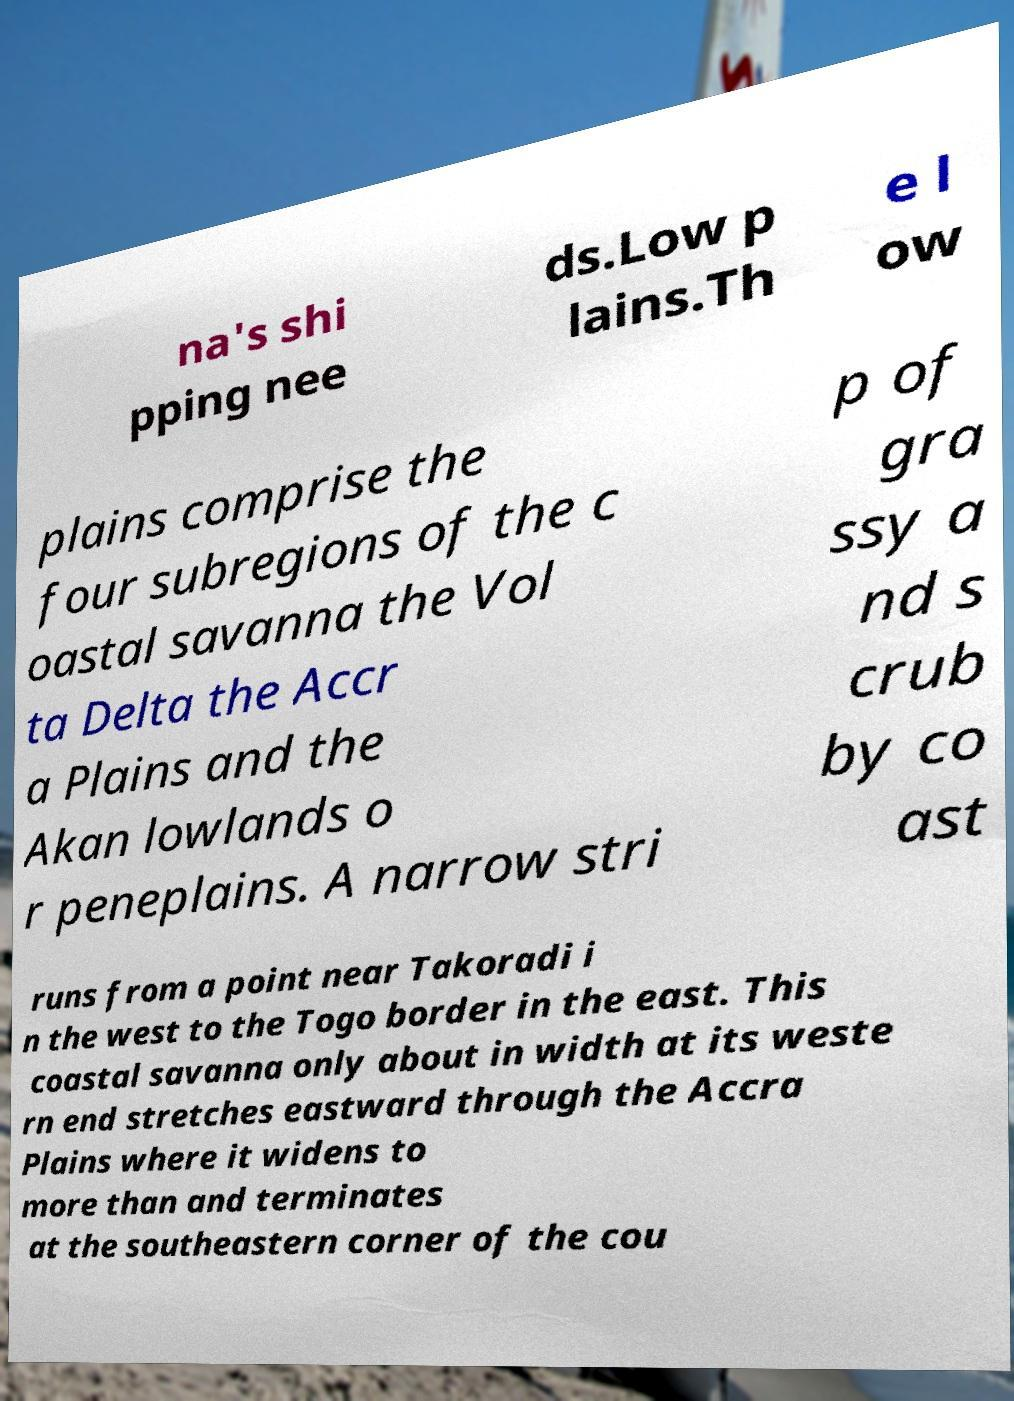Please identify and transcribe the text found in this image. na's shi pping nee ds.Low p lains.Th e l ow plains comprise the four subregions of the c oastal savanna the Vol ta Delta the Accr a Plains and the Akan lowlands o r peneplains. A narrow stri p of gra ssy a nd s crub by co ast runs from a point near Takoradi i n the west to the Togo border in the east. This coastal savanna only about in width at its weste rn end stretches eastward through the Accra Plains where it widens to more than and terminates at the southeastern corner of the cou 